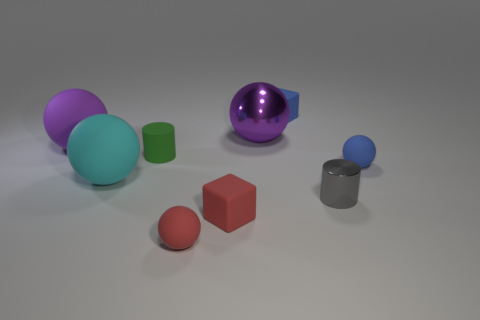Subtract all blue balls. How many balls are left? 4 Subtract all brown cubes. Subtract all yellow spheres. How many cubes are left? 2 Subtract all cylinders. How many objects are left? 7 Subtract 0 yellow cylinders. How many objects are left? 9 Subtract all small blue things. Subtract all large yellow cubes. How many objects are left? 7 Add 2 blocks. How many blocks are left? 4 Add 4 gray objects. How many gray objects exist? 5 